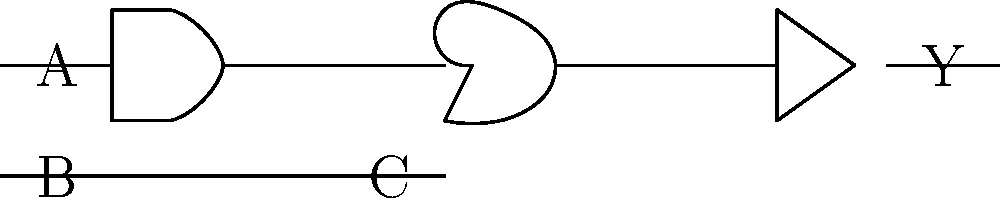In the digital circuit diagram above, identify the logic gates used and express the output Y in terms of inputs A, B, and C. How might this circuit be useful in designing a scoreboard for the Laune Rangers football team? Let's break this down step-by-step:

1. Identify the logic gates:
   - The first gate (from left to right) is an AND gate
   - The second gate is an OR gate
   - The third gate is a NOT gate (inverter)

2. Express the output Y in terms of inputs:
   - The AND gate takes inputs A and B, producing $(A \cdot B)$
   - The OR gate takes the output of the AND gate and input C, producing $(A \cdot B + C)$
   - The NOT gate inverts the output of the OR gate

   Therefore, the final output Y can be expressed as:
   $Y = \overline{(A \cdot B + C)}$

3. Relevance to Laune Rangers scoreboard:
   This circuit could be part of a larger system in a digital scoreboard. For example:
   - A could represent "Home team scored"
   - B could represent "Valid goal" (to distinguish from other score types)
   - C could represent "Away team scored"
   - Y could then represent "No valid score by either team"

   This would be useful for updating the display only when a valid score occurs, and could be part of a system that your great-grandfather might have appreciated if such technology existed during his time playing for the Laune Rangers.
Answer: $Y = \overline{(A \cdot B + C)}$, representing "No valid score by either team" in a digital scoreboard system. 